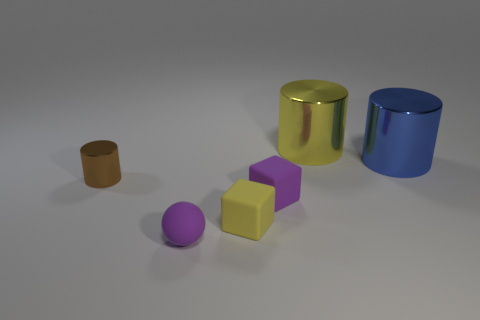There is a blue thing that is behind the small sphere; is its size the same as the rubber object behind the yellow rubber object?
Your response must be concise. No. Are there fewer brown shiny cylinders than large yellow metal balls?
Your answer should be compact. No. What number of shiny things are either tiny brown objects or purple balls?
Your answer should be compact. 1. Is there a blue shiny cylinder left of the big metal thing that is on the right side of the yellow cylinder?
Give a very brief answer. No. Does the large cylinder that is behind the big blue shiny cylinder have the same material as the purple block?
Provide a succinct answer. No. What number of other objects are the same color as the small metallic cylinder?
Your answer should be very brief. 0. How big is the purple rubber thing to the right of the yellow object on the left side of the large yellow cylinder?
Your answer should be very brief. Small. Does the tiny purple thing behind the small purple rubber sphere have the same material as the small brown cylinder that is behind the tiny yellow cube?
Provide a succinct answer. No. Is the color of the rubber thing behind the small yellow rubber thing the same as the ball?
Ensure brevity in your answer.  Yes. What number of big yellow cylinders are in front of the yellow matte thing?
Your response must be concise. 0. 